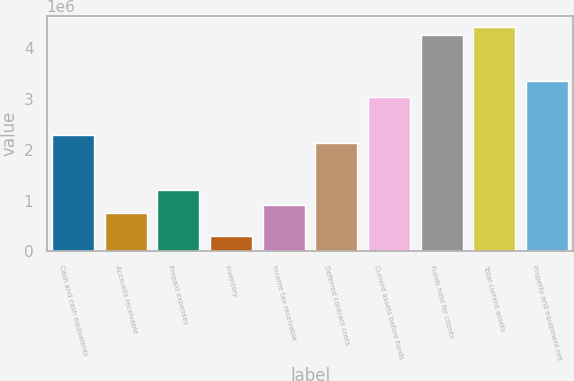<chart> <loc_0><loc_0><loc_500><loc_500><bar_chart><fcel>Cash and cash equivalents<fcel>Accounts receivable<fcel>Prepaid expenses<fcel>Inventory<fcel>Income tax receivable<fcel>Deferred contract costs<fcel>Current assets before funds<fcel>Funds held for clients<fcel>Total current assets<fcel>Property and equipment net<nl><fcel>2.28259e+06<fcel>761266<fcel>1.21766e+06<fcel>304871<fcel>913398<fcel>2.13045e+06<fcel>3.04324e+06<fcel>4.2603e+06<fcel>4.41243e+06<fcel>3.34751e+06<nl></chart> 